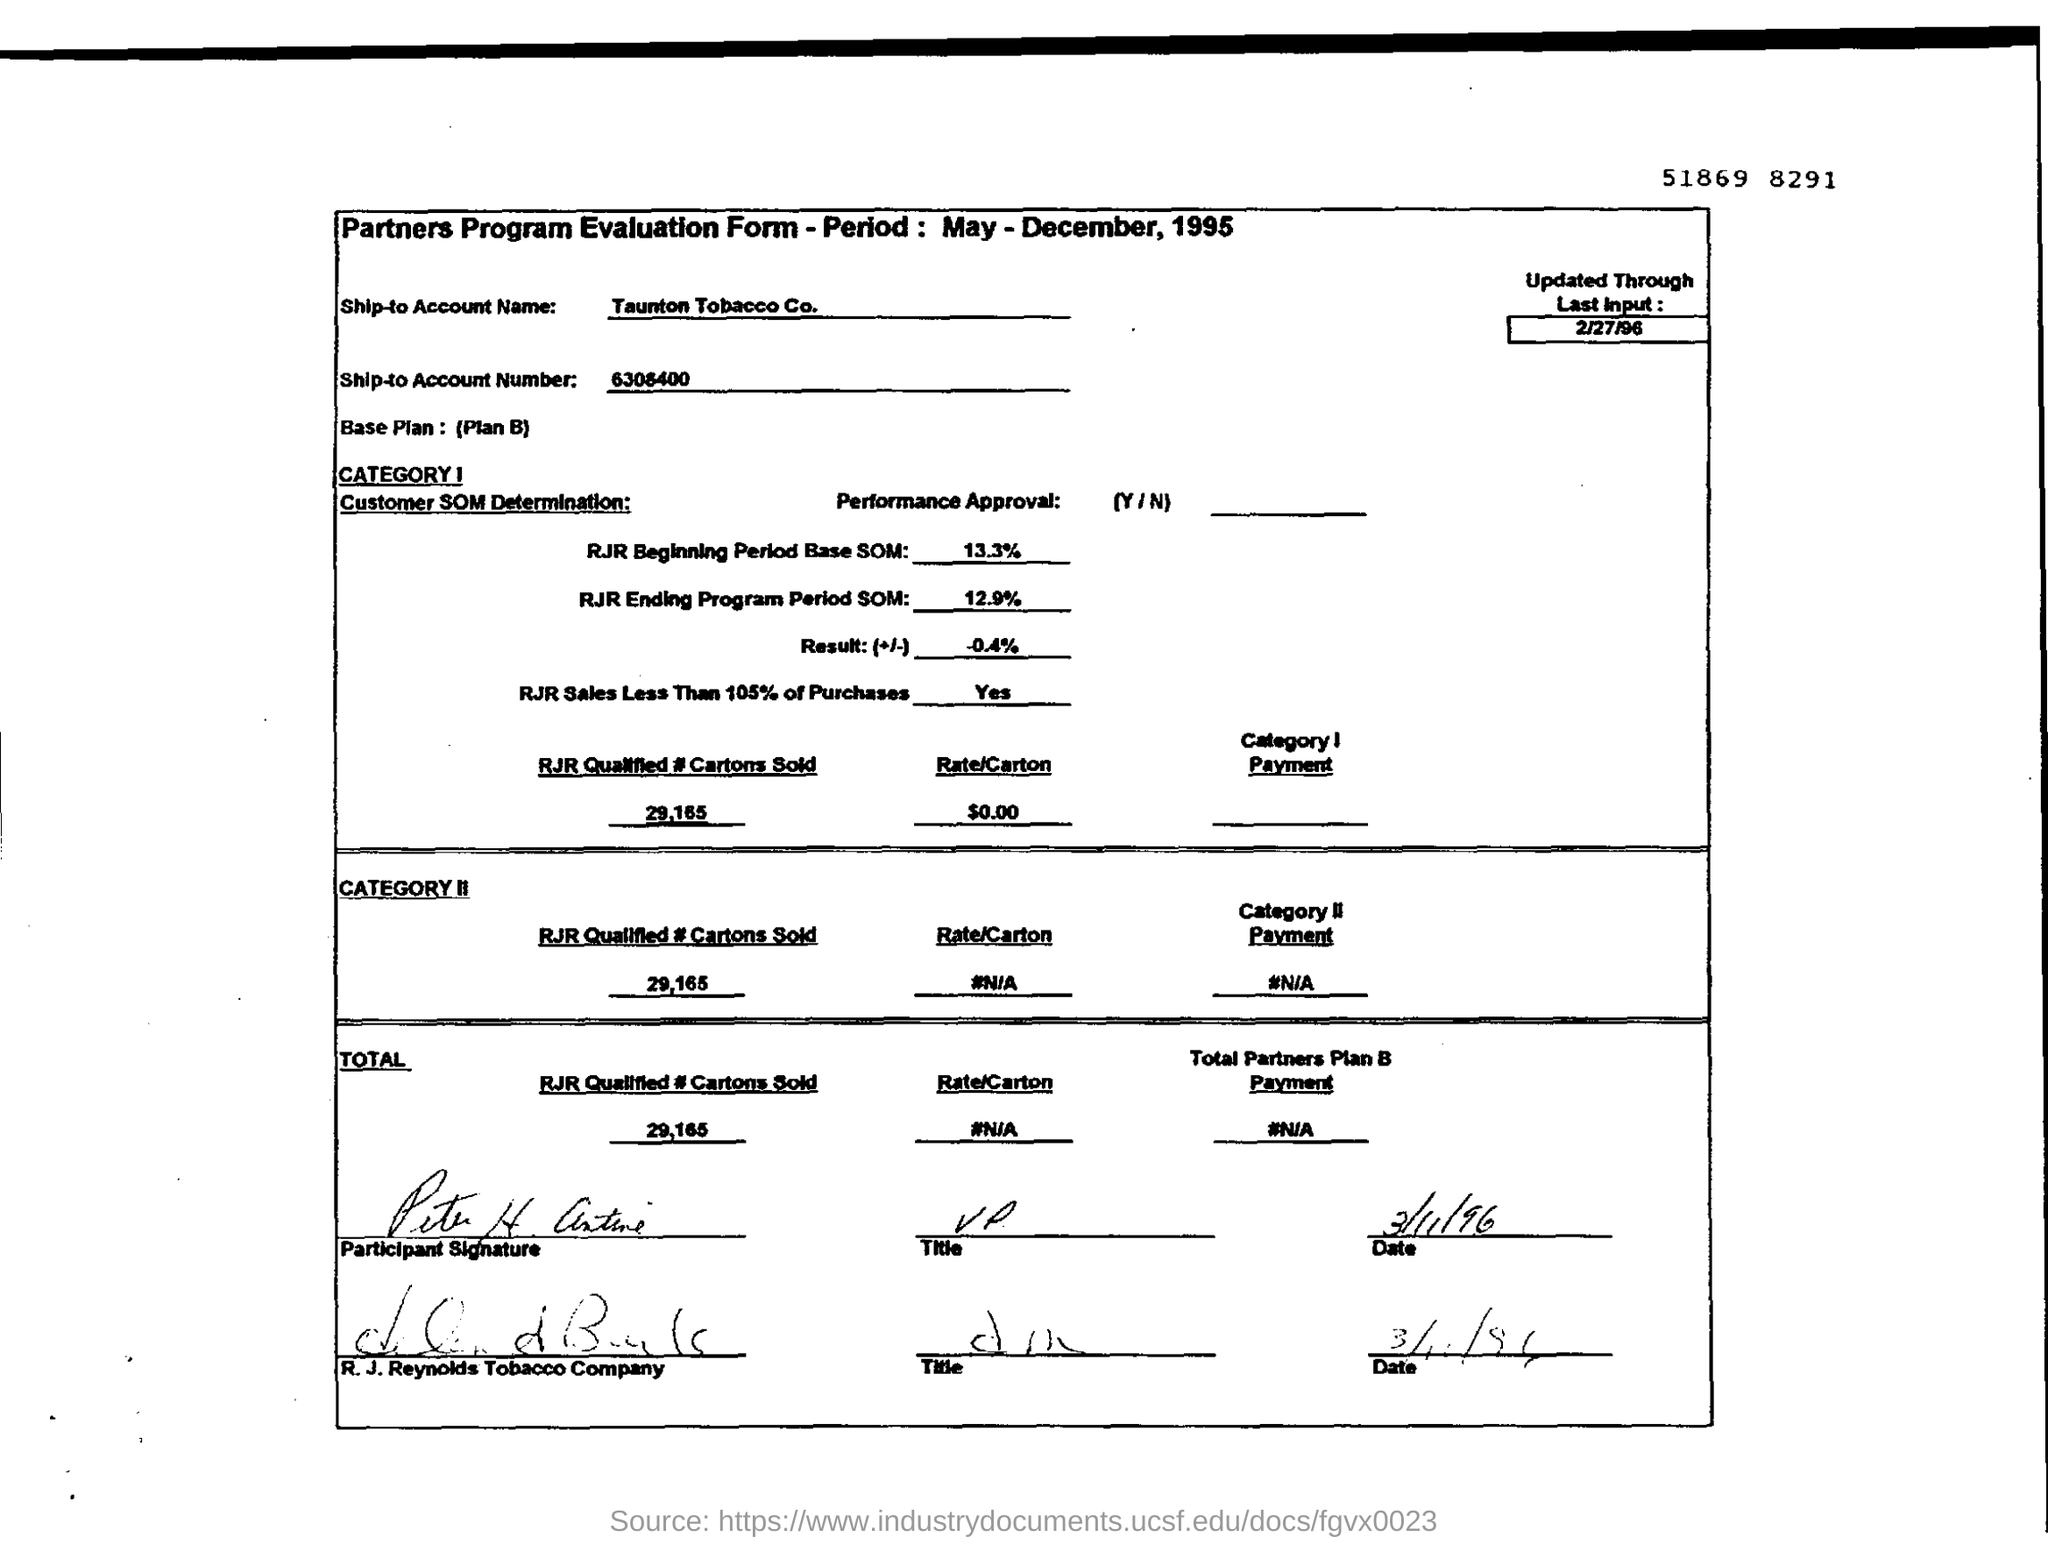What is RJR Beginning Period Base SOM
Offer a very short reply. 13.3%. 